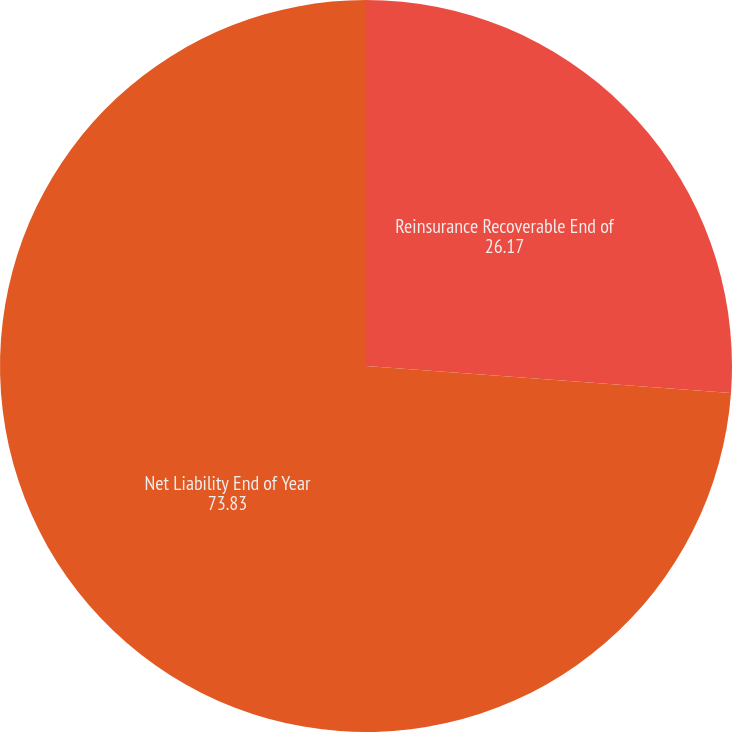<chart> <loc_0><loc_0><loc_500><loc_500><pie_chart><fcel>Reinsurance Recoverable End of<fcel>Net Liability End of Year<nl><fcel>26.17%<fcel>73.83%<nl></chart> 